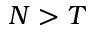<formula> <loc_0><loc_0><loc_500><loc_500>N > T</formula> 